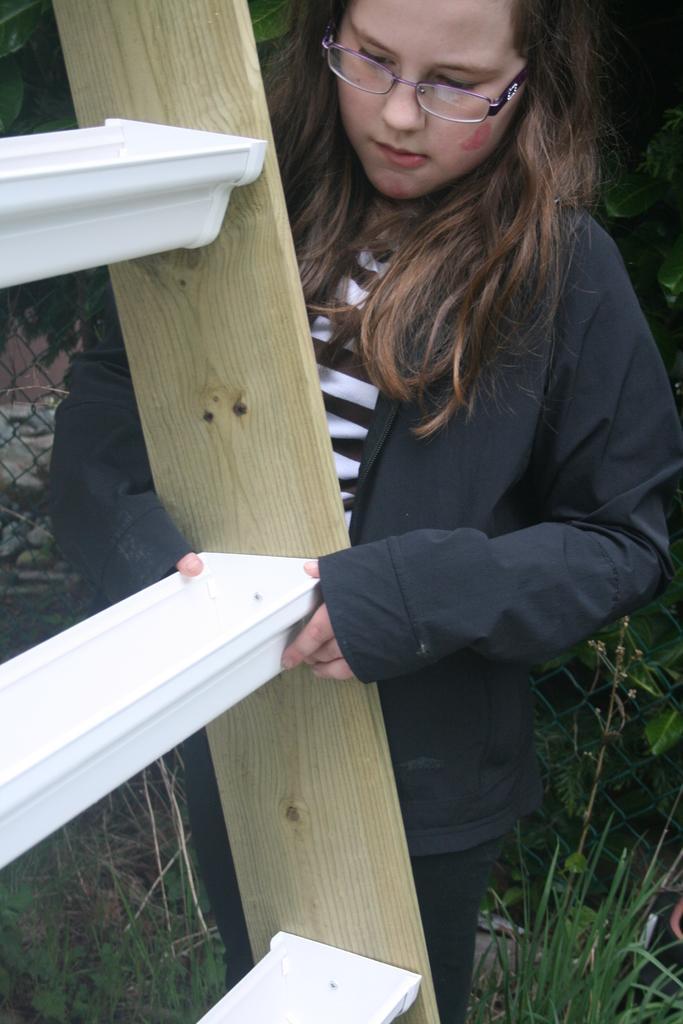Can you describe this image briefly? In this picture we can see a woman, she wore spectacles, in front of her we can see a ladder, beside to her we can see grass and fence. 